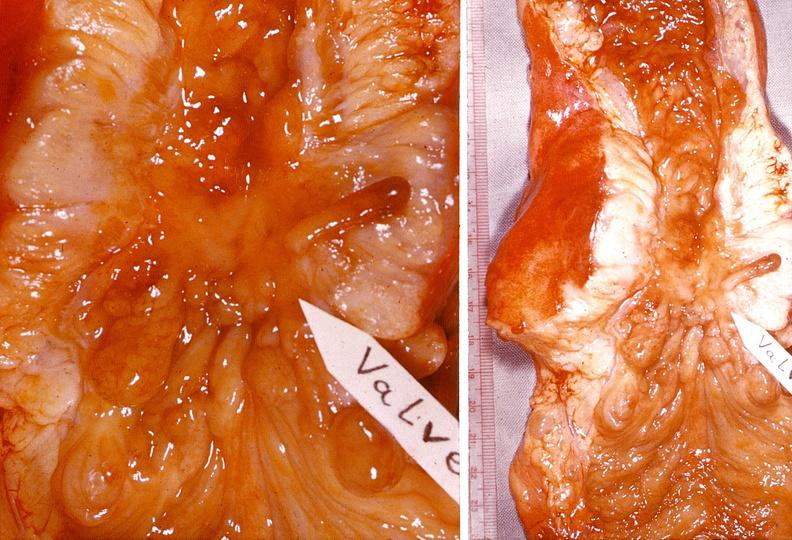s fat necrosis present?
Answer the question using a single word or phrase. No 